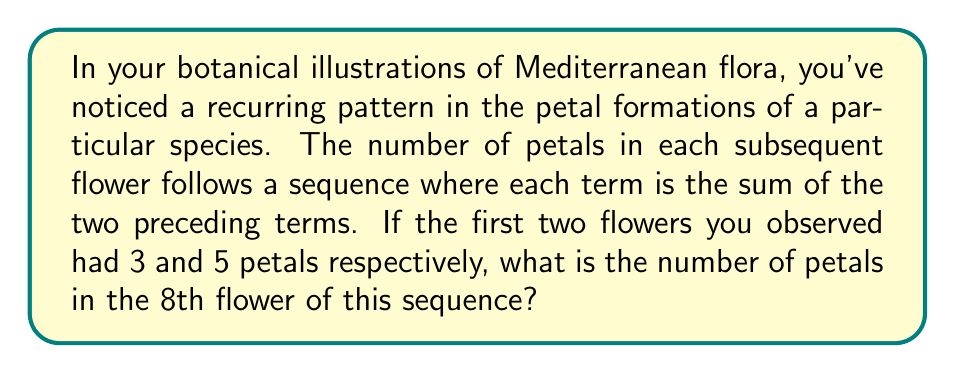Can you answer this question? Let's approach this step-by-step:

1) We're dealing with a sequence where each term is the sum of the two preceding terms. This is known as the Fibonacci sequence.

2) We're given the first two terms:
   $a_1 = 3$
   $a_2 = 5$

3) Let's calculate the subsequent terms:
   $a_3 = a_1 + a_2 = 3 + 5 = 8$
   $a_4 = a_2 + a_3 = 5 + 8 = 13$
   $a_5 = a_3 + a_4 = 8 + 13 = 21$
   $a_6 = a_4 + a_5 = 13 + 21 = 34$
   $a_7 = a_5 + a_6 = 21 + 34 = 55$
   $a_8 = a_6 + a_7 = 34 + 55 = 89$

4) Therefore, the 8th flower in the sequence will have 89 petals.

This Fibonacci-like pattern is often observed in nature, particularly in the arrangement of petals, leaves, and seeds in plants. It's an example of the fascinating intersection between mathematics and botany that a botanical illustrator might observe.
Answer: 89 